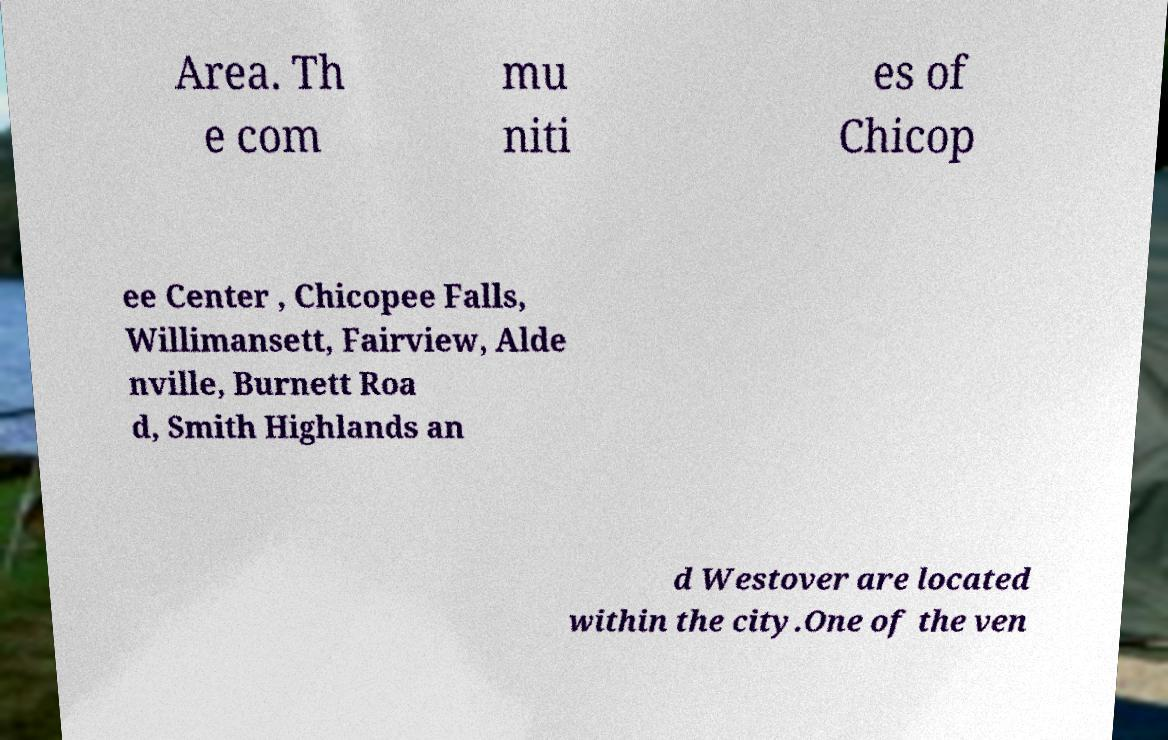Could you assist in decoding the text presented in this image and type it out clearly? Area. Th e com mu niti es of Chicop ee Center , Chicopee Falls, Willimansett, Fairview, Alde nville, Burnett Roa d, Smith Highlands an d Westover are located within the city.One of the ven 